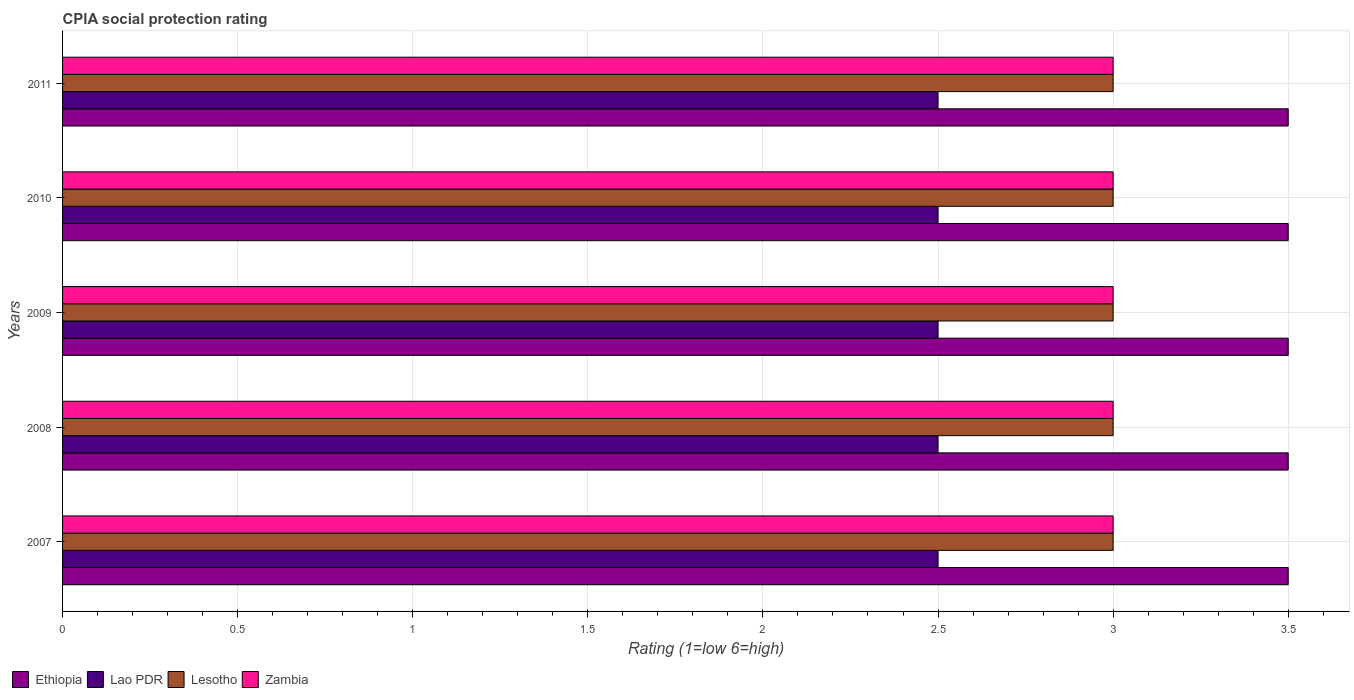How many groups of bars are there?
Keep it short and to the point. 5. Are the number of bars on each tick of the Y-axis equal?
Offer a very short reply. Yes. How many bars are there on the 5th tick from the top?
Provide a short and direct response. 4. How many bars are there on the 2nd tick from the bottom?
Provide a succinct answer. 4. What is the label of the 5th group of bars from the top?
Offer a very short reply. 2007. In how many cases, is the number of bars for a given year not equal to the number of legend labels?
Ensure brevity in your answer.  0. What is the CPIA rating in Zambia in 2009?
Your response must be concise. 3. Across all years, what is the maximum CPIA rating in Ethiopia?
Your answer should be compact. 3.5. Across all years, what is the minimum CPIA rating in Zambia?
Make the answer very short. 3. In which year was the CPIA rating in Ethiopia minimum?
Your response must be concise. 2007. What is the difference between the CPIA rating in Lesotho in 2009 and the CPIA rating in Ethiopia in 2007?
Provide a succinct answer. -0.5. What is the average CPIA rating in Zambia per year?
Keep it short and to the point. 3. Is the CPIA rating in Lao PDR in 2007 less than that in 2009?
Keep it short and to the point. No. What is the difference between the highest and the lowest CPIA rating in Zambia?
Your answer should be very brief. 0. Is the sum of the CPIA rating in Ethiopia in 2007 and 2011 greater than the maximum CPIA rating in Zambia across all years?
Ensure brevity in your answer.  Yes. What does the 4th bar from the top in 2011 represents?
Your answer should be very brief. Ethiopia. What does the 3rd bar from the bottom in 2010 represents?
Keep it short and to the point. Lesotho. How many bars are there?
Give a very brief answer. 20. What is the difference between two consecutive major ticks on the X-axis?
Offer a terse response. 0.5. Does the graph contain any zero values?
Provide a succinct answer. No. Does the graph contain grids?
Your answer should be compact. Yes. Where does the legend appear in the graph?
Offer a very short reply. Bottom left. What is the title of the graph?
Your answer should be very brief. CPIA social protection rating. What is the label or title of the X-axis?
Your answer should be very brief. Rating (1=low 6=high). What is the Rating (1=low 6=high) in Ethiopia in 2007?
Your answer should be very brief. 3.5. What is the Rating (1=low 6=high) in Lao PDR in 2007?
Keep it short and to the point. 2.5. What is the Rating (1=low 6=high) of Lesotho in 2007?
Offer a terse response. 3. What is the Rating (1=low 6=high) of Ethiopia in 2008?
Give a very brief answer. 3.5. What is the Rating (1=low 6=high) in Lao PDR in 2008?
Ensure brevity in your answer.  2.5. What is the Rating (1=low 6=high) in Lao PDR in 2009?
Give a very brief answer. 2.5. What is the Rating (1=low 6=high) in Lesotho in 2009?
Provide a succinct answer. 3. What is the Rating (1=low 6=high) of Zambia in 2009?
Ensure brevity in your answer.  3. What is the Rating (1=low 6=high) in Ethiopia in 2010?
Provide a succinct answer. 3.5. What is the Rating (1=low 6=high) in Lesotho in 2010?
Offer a terse response. 3. What is the Rating (1=low 6=high) of Lao PDR in 2011?
Ensure brevity in your answer.  2.5. What is the Rating (1=low 6=high) in Lesotho in 2011?
Offer a very short reply. 3. What is the Rating (1=low 6=high) in Zambia in 2011?
Your response must be concise. 3. Across all years, what is the maximum Rating (1=low 6=high) in Ethiopia?
Make the answer very short. 3.5. Across all years, what is the maximum Rating (1=low 6=high) of Lao PDR?
Offer a terse response. 2.5. Across all years, what is the maximum Rating (1=low 6=high) in Lesotho?
Make the answer very short. 3. Across all years, what is the minimum Rating (1=low 6=high) of Lao PDR?
Offer a terse response. 2.5. What is the difference between the Rating (1=low 6=high) in Ethiopia in 2007 and that in 2008?
Your answer should be very brief. 0. What is the difference between the Rating (1=low 6=high) of Lao PDR in 2007 and that in 2008?
Ensure brevity in your answer.  0. What is the difference between the Rating (1=low 6=high) in Zambia in 2007 and that in 2008?
Provide a short and direct response. 0. What is the difference between the Rating (1=low 6=high) in Lao PDR in 2007 and that in 2009?
Keep it short and to the point. 0. What is the difference between the Rating (1=low 6=high) of Lesotho in 2007 and that in 2009?
Keep it short and to the point. 0. What is the difference between the Rating (1=low 6=high) of Ethiopia in 2007 and that in 2010?
Your answer should be compact. 0. What is the difference between the Rating (1=low 6=high) of Lao PDR in 2007 and that in 2010?
Your response must be concise. 0. What is the difference between the Rating (1=low 6=high) of Lesotho in 2007 and that in 2010?
Your answer should be compact. 0. What is the difference between the Rating (1=low 6=high) in Zambia in 2007 and that in 2010?
Provide a short and direct response. 0. What is the difference between the Rating (1=low 6=high) in Ethiopia in 2007 and that in 2011?
Your answer should be compact. 0. What is the difference between the Rating (1=low 6=high) of Lesotho in 2007 and that in 2011?
Offer a terse response. 0. What is the difference between the Rating (1=low 6=high) in Zambia in 2007 and that in 2011?
Make the answer very short. 0. What is the difference between the Rating (1=low 6=high) of Ethiopia in 2008 and that in 2009?
Your answer should be compact. 0. What is the difference between the Rating (1=low 6=high) in Lao PDR in 2008 and that in 2009?
Ensure brevity in your answer.  0. What is the difference between the Rating (1=low 6=high) of Lao PDR in 2008 and that in 2010?
Keep it short and to the point. 0. What is the difference between the Rating (1=low 6=high) in Lao PDR in 2008 and that in 2011?
Keep it short and to the point. 0. What is the difference between the Rating (1=low 6=high) of Lesotho in 2008 and that in 2011?
Keep it short and to the point. 0. What is the difference between the Rating (1=low 6=high) of Lao PDR in 2009 and that in 2010?
Make the answer very short. 0. What is the difference between the Rating (1=low 6=high) in Lesotho in 2009 and that in 2010?
Make the answer very short. 0. What is the difference between the Rating (1=low 6=high) of Zambia in 2009 and that in 2010?
Provide a succinct answer. 0. What is the difference between the Rating (1=low 6=high) in Ethiopia in 2009 and that in 2011?
Your answer should be compact. 0. What is the difference between the Rating (1=low 6=high) of Lesotho in 2009 and that in 2011?
Offer a terse response. 0. What is the difference between the Rating (1=low 6=high) of Ethiopia in 2010 and that in 2011?
Provide a succinct answer. 0. What is the difference between the Rating (1=low 6=high) of Lesotho in 2010 and that in 2011?
Your answer should be very brief. 0. What is the difference between the Rating (1=low 6=high) in Zambia in 2010 and that in 2011?
Your answer should be very brief. 0. What is the difference between the Rating (1=low 6=high) in Ethiopia in 2007 and the Rating (1=low 6=high) in Lao PDR in 2008?
Ensure brevity in your answer.  1. What is the difference between the Rating (1=low 6=high) of Lao PDR in 2007 and the Rating (1=low 6=high) of Zambia in 2008?
Ensure brevity in your answer.  -0.5. What is the difference between the Rating (1=low 6=high) in Ethiopia in 2007 and the Rating (1=low 6=high) in Lao PDR in 2009?
Offer a very short reply. 1. What is the difference between the Rating (1=low 6=high) of Ethiopia in 2007 and the Rating (1=low 6=high) of Lesotho in 2009?
Your response must be concise. 0.5. What is the difference between the Rating (1=low 6=high) in Lao PDR in 2007 and the Rating (1=low 6=high) in Lesotho in 2009?
Provide a succinct answer. -0.5. What is the difference between the Rating (1=low 6=high) in Lao PDR in 2007 and the Rating (1=low 6=high) in Zambia in 2009?
Your response must be concise. -0.5. What is the difference between the Rating (1=low 6=high) in Ethiopia in 2007 and the Rating (1=low 6=high) in Lao PDR in 2010?
Give a very brief answer. 1. What is the difference between the Rating (1=low 6=high) of Ethiopia in 2007 and the Rating (1=low 6=high) of Lesotho in 2010?
Provide a succinct answer. 0.5. What is the difference between the Rating (1=low 6=high) of Lao PDR in 2007 and the Rating (1=low 6=high) of Zambia in 2010?
Ensure brevity in your answer.  -0.5. What is the difference between the Rating (1=low 6=high) in Lao PDR in 2007 and the Rating (1=low 6=high) in Lesotho in 2011?
Your answer should be very brief. -0.5. What is the difference between the Rating (1=low 6=high) of Lao PDR in 2007 and the Rating (1=low 6=high) of Zambia in 2011?
Give a very brief answer. -0.5. What is the difference between the Rating (1=low 6=high) in Lesotho in 2007 and the Rating (1=low 6=high) in Zambia in 2011?
Provide a short and direct response. 0. What is the difference between the Rating (1=low 6=high) of Ethiopia in 2008 and the Rating (1=low 6=high) of Lao PDR in 2009?
Offer a terse response. 1. What is the difference between the Rating (1=low 6=high) in Ethiopia in 2008 and the Rating (1=low 6=high) in Lesotho in 2009?
Your response must be concise. 0.5. What is the difference between the Rating (1=low 6=high) of Ethiopia in 2008 and the Rating (1=low 6=high) of Zambia in 2009?
Your answer should be compact. 0.5. What is the difference between the Rating (1=low 6=high) of Lao PDR in 2008 and the Rating (1=low 6=high) of Lesotho in 2009?
Keep it short and to the point. -0.5. What is the difference between the Rating (1=low 6=high) in Lesotho in 2008 and the Rating (1=low 6=high) in Zambia in 2009?
Make the answer very short. 0. What is the difference between the Rating (1=low 6=high) of Ethiopia in 2008 and the Rating (1=low 6=high) of Lao PDR in 2010?
Provide a short and direct response. 1. What is the difference between the Rating (1=low 6=high) of Ethiopia in 2008 and the Rating (1=low 6=high) of Lesotho in 2010?
Your response must be concise. 0.5. What is the difference between the Rating (1=low 6=high) of Lao PDR in 2008 and the Rating (1=low 6=high) of Lesotho in 2010?
Make the answer very short. -0.5. What is the difference between the Rating (1=low 6=high) in Lesotho in 2008 and the Rating (1=low 6=high) in Zambia in 2010?
Offer a terse response. 0. What is the difference between the Rating (1=low 6=high) of Ethiopia in 2008 and the Rating (1=low 6=high) of Lao PDR in 2011?
Ensure brevity in your answer.  1. What is the difference between the Rating (1=low 6=high) of Ethiopia in 2008 and the Rating (1=low 6=high) of Zambia in 2011?
Provide a short and direct response. 0.5. What is the difference between the Rating (1=low 6=high) of Lao PDR in 2008 and the Rating (1=low 6=high) of Lesotho in 2011?
Your answer should be compact. -0.5. What is the difference between the Rating (1=low 6=high) of Ethiopia in 2009 and the Rating (1=low 6=high) of Lao PDR in 2010?
Keep it short and to the point. 1. What is the difference between the Rating (1=low 6=high) in Ethiopia in 2009 and the Rating (1=low 6=high) in Lesotho in 2010?
Offer a very short reply. 0.5. What is the difference between the Rating (1=low 6=high) of Ethiopia in 2009 and the Rating (1=low 6=high) of Zambia in 2010?
Your answer should be very brief. 0.5. What is the difference between the Rating (1=low 6=high) in Lao PDR in 2009 and the Rating (1=low 6=high) in Lesotho in 2010?
Offer a terse response. -0.5. What is the difference between the Rating (1=low 6=high) in Ethiopia in 2009 and the Rating (1=low 6=high) in Lao PDR in 2011?
Ensure brevity in your answer.  1. What is the difference between the Rating (1=low 6=high) of Ethiopia in 2009 and the Rating (1=low 6=high) of Zambia in 2011?
Offer a very short reply. 0.5. What is the difference between the Rating (1=low 6=high) in Ethiopia in 2010 and the Rating (1=low 6=high) in Lao PDR in 2011?
Provide a succinct answer. 1. What is the difference between the Rating (1=low 6=high) in Ethiopia in 2010 and the Rating (1=low 6=high) in Lesotho in 2011?
Ensure brevity in your answer.  0.5. What is the difference between the Rating (1=low 6=high) of Ethiopia in 2010 and the Rating (1=low 6=high) of Zambia in 2011?
Offer a very short reply. 0.5. What is the difference between the Rating (1=low 6=high) in Lao PDR in 2010 and the Rating (1=low 6=high) in Lesotho in 2011?
Your response must be concise. -0.5. What is the average Rating (1=low 6=high) in Ethiopia per year?
Ensure brevity in your answer.  3.5. What is the average Rating (1=low 6=high) in Lao PDR per year?
Ensure brevity in your answer.  2.5. In the year 2007, what is the difference between the Rating (1=low 6=high) of Lao PDR and Rating (1=low 6=high) of Lesotho?
Give a very brief answer. -0.5. In the year 2007, what is the difference between the Rating (1=low 6=high) in Lao PDR and Rating (1=low 6=high) in Zambia?
Your answer should be very brief. -0.5. In the year 2008, what is the difference between the Rating (1=low 6=high) of Ethiopia and Rating (1=low 6=high) of Lao PDR?
Provide a short and direct response. 1. In the year 2008, what is the difference between the Rating (1=low 6=high) of Ethiopia and Rating (1=low 6=high) of Lesotho?
Keep it short and to the point. 0.5. In the year 2008, what is the difference between the Rating (1=low 6=high) in Lao PDR and Rating (1=low 6=high) in Lesotho?
Provide a short and direct response. -0.5. In the year 2008, what is the difference between the Rating (1=low 6=high) in Lesotho and Rating (1=low 6=high) in Zambia?
Make the answer very short. 0. In the year 2009, what is the difference between the Rating (1=low 6=high) in Ethiopia and Rating (1=low 6=high) in Lao PDR?
Offer a terse response. 1. In the year 2009, what is the difference between the Rating (1=low 6=high) in Ethiopia and Rating (1=low 6=high) in Lesotho?
Give a very brief answer. 0.5. In the year 2009, what is the difference between the Rating (1=low 6=high) of Ethiopia and Rating (1=low 6=high) of Zambia?
Your answer should be compact. 0.5. In the year 2009, what is the difference between the Rating (1=low 6=high) of Lao PDR and Rating (1=low 6=high) of Lesotho?
Provide a succinct answer. -0.5. In the year 2009, what is the difference between the Rating (1=low 6=high) in Lesotho and Rating (1=low 6=high) in Zambia?
Provide a short and direct response. 0. In the year 2010, what is the difference between the Rating (1=low 6=high) of Ethiopia and Rating (1=low 6=high) of Zambia?
Give a very brief answer. 0.5. In the year 2010, what is the difference between the Rating (1=low 6=high) in Lao PDR and Rating (1=low 6=high) in Zambia?
Ensure brevity in your answer.  -0.5. In the year 2010, what is the difference between the Rating (1=low 6=high) of Lesotho and Rating (1=low 6=high) of Zambia?
Give a very brief answer. 0. In the year 2011, what is the difference between the Rating (1=low 6=high) of Ethiopia and Rating (1=low 6=high) of Lesotho?
Give a very brief answer. 0.5. In the year 2011, what is the difference between the Rating (1=low 6=high) in Lao PDR and Rating (1=low 6=high) in Zambia?
Make the answer very short. -0.5. In the year 2011, what is the difference between the Rating (1=low 6=high) in Lesotho and Rating (1=low 6=high) in Zambia?
Your response must be concise. 0. What is the ratio of the Rating (1=low 6=high) of Lesotho in 2007 to that in 2008?
Provide a short and direct response. 1. What is the ratio of the Rating (1=low 6=high) in Zambia in 2007 to that in 2008?
Give a very brief answer. 1. What is the ratio of the Rating (1=low 6=high) of Lesotho in 2007 to that in 2009?
Ensure brevity in your answer.  1. What is the ratio of the Rating (1=low 6=high) in Lesotho in 2007 to that in 2010?
Offer a terse response. 1. What is the ratio of the Rating (1=low 6=high) of Zambia in 2007 to that in 2010?
Give a very brief answer. 1. What is the ratio of the Rating (1=low 6=high) in Ethiopia in 2007 to that in 2011?
Keep it short and to the point. 1. What is the ratio of the Rating (1=low 6=high) of Lao PDR in 2007 to that in 2011?
Make the answer very short. 1. What is the ratio of the Rating (1=low 6=high) in Lesotho in 2007 to that in 2011?
Offer a terse response. 1. What is the ratio of the Rating (1=low 6=high) of Ethiopia in 2008 to that in 2009?
Provide a succinct answer. 1. What is the ratio of the Rating (1=low 6=high) in Lao PDR in 2008 to that in 2009?
Offer a very short reply. 1. What is the ratio of the Rating (1=low 6=high) of Lesotho in 2008 to that in 2009?
Keep it short and to the point. 1. What is the ratio of the Rating (1=low 6=high) in Zambia in 2008 to that in 2009?
Your answer should be compact. 1. What is the ratio of the Rating (1=low 6=high) of Ethiopia in 2008 to that in 2010?
Give a very brief answer. 1. What is the ratio of the Rating (1=low 6=high) of Zambia in 2008 to that in 2010?
Offer a very short reply. 1. What is the ratio of the Rating (1=low 6=high) in Ethiopia in 2008 to that in 2011?
Provide a short and direct response. 1. What is the ratio of the Rating (1=low 6=high) in Lesotho in 2008 to that in 2011?
Make the answer very short. 1. What is the ratio of the Rating (1=low 6=high) in Zambia in 2008 to that in 2011?
Your response must be concise. 1. What is the ratio of the Rating (1=low 6=high) of Ethiopia in 2009 to that in 2010?
Keep it short and to the point. 1. What is the ratio of the Rating (1=low 6=high) in Lao PDR in 2009 to that in 2010?
Your answer should be very brief. 1. What is the ratio of the Rating (1=low 6=high) of Lesotho in 2009 to that in 2010?
Give a very brief answer. 1. What is the ratio of the Rating (1=low 6=high) in Zambia in 2009 to that in 2010?
Provide a succinct answer. 1. What is the ratio of the Rating (1=low 6=high) in Lesotho in 2009 to that in 2011?
Keep it short and to the point. 1. What is the ratio of the Rating (1=low 6=high) in Lesotho in 2010 to that in 2011?
Ensure brevity in your answer.  1. What is the difference between the highest and the second highest Rating (1=low 6=high) in Ethiopia?
Offer a very short reply. 0. What is the difference between the highest and the second highest Rating (1=low 6=high) of Lao PDR?
Your answer should be compact. 0. What is the difference between the highest and the lowest Rating (1=low 6=high) in Ethiopia?
Provide a succinct answer. 0. What is the difference between the highest and the lowest Rating (1=low 6=high) in Lao PDR?
Offer a terse response. 0. What is the difference between the highest and the lowest Rating (1=low 6=high) of Lesotho?
Provide a short and direct response. 0. What is the difference between the highest and the lowest Rating (1=low 6=high) of Zambia?
Provide a short and direct response. 0. 